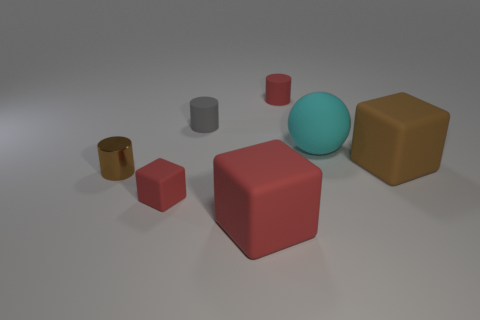Are there any other things that are the same material as the tiny brown cylinder?
Offer a very short reply. No. How many brown blocks are to the left of the large red block?
Your answer should be compact. 0. There is a matte cube that is to the right of the cyan rubber object; does it have the same size as the cube to the left of the gray thing?
Offer a terse response. No. How many other objects are there of the same size as the cyan matte sphere?
Offer a terse response. 2. What material is the small red thing that is in front of the small rubber cylinder left of the tiny red object that is to the right of the tiny rubber block?
Make the answer very short. Rubber. Is the size of the shiny cylinder the same as the red rubber object that is behind the brown matte block?
Provide a succinct answer. Yes. There is a cylinder that is to the right of the shiny thing and in front of the red cylinder; what size is it?
Ensure brevity in your answer.  Small. Is there a big sphere that has the same color as the metal cylinder?
Keep it short and to the point. No. There is a large matte cube that is in front of the rubber cube behind the tiny brown shiny object; what color is it?
Make the answer very short. Red. Is the number of balls to the left of the gray matte cylinder less than the number of small red things that are right of the red matte cylinder?
Provide a short and direct response. No. 